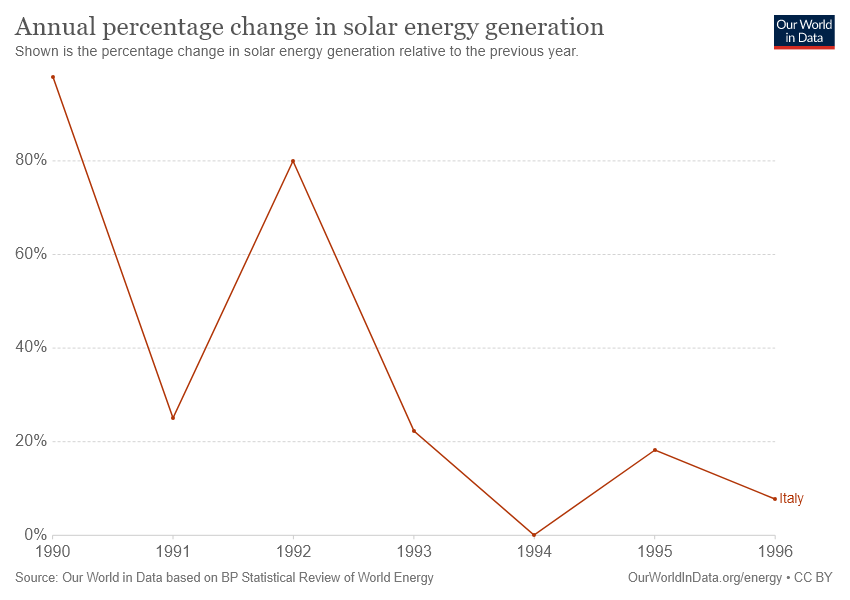Outline some significant characteristics in this image. What is the distinction between the starting year of a line and the conclusion year of a line? The line was established in 6.. The graph contains 1 line. 